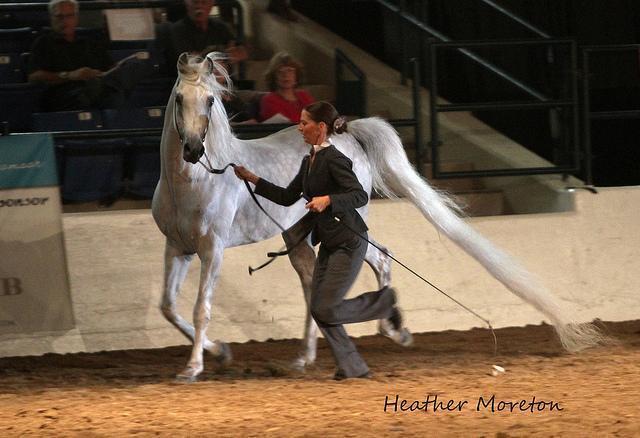How many people are there?
Give a very brief answer. 4. How many feet of the elephant are on the ground?
Give a very brief answer. 0. 